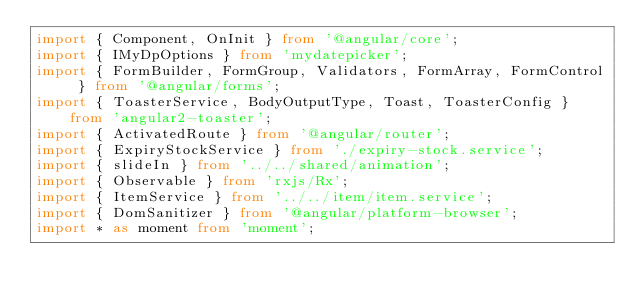Convert code to text. <code><loc_0><loc_0><loc_500><loc_500><_TypeScript_>import { Component, OnInit } from '@angular/core';
import { IMyDpOptions } from 'mydatepicker';
import { FormBuilder, FormGroup, Validators, FormArray, FormControl } from '@angular/forms';
import { ToasterService, BodyOutputType, Toast, ToasterConfig } from 'angular2-toaster';
import { ActivatedRoute } from '@angular/router';
import { ExpiryStockService } from './expiry-stock.service';
import { slideIn } from '../../shared/animation';
import { Observable } from 'rxjs/Rx';
import { ItemService } from '../../item/item.service';
import { DomSanitizer } from '@angular/platform-browser';
import * as moment from 'moment';</code> 